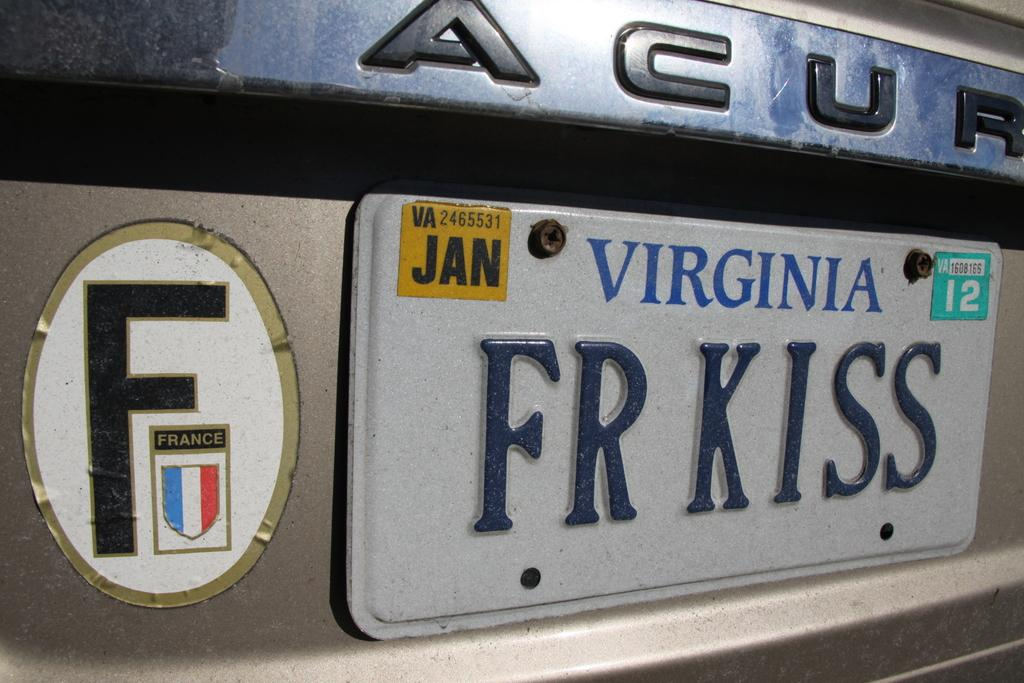Provide a one-sentence caption for the provided image. A close up of an Acura with a Virginia license plate that says FR KISS. 